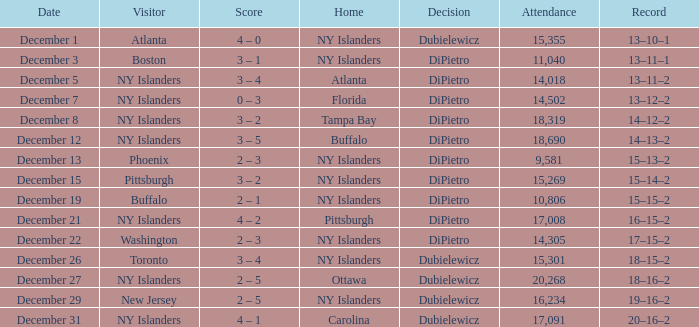What is the date when the attendance surpassed 20,268? None. 